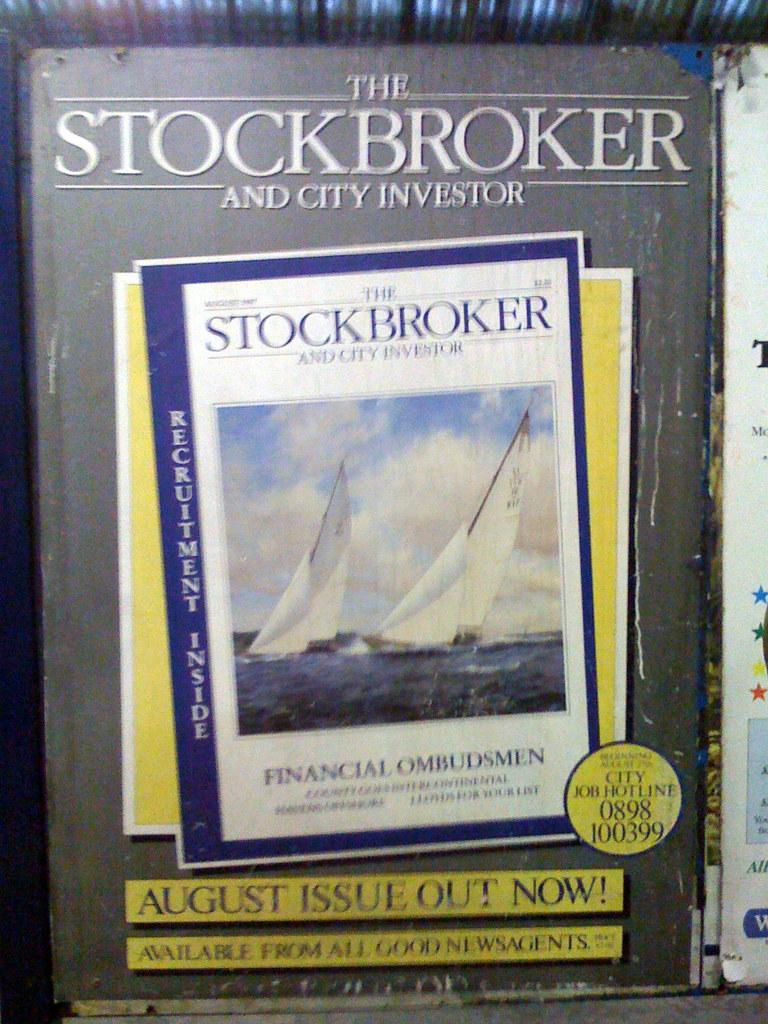<image>
Describe the image concisely. front of the stockbroker and city investor stating that the august issue is out now 